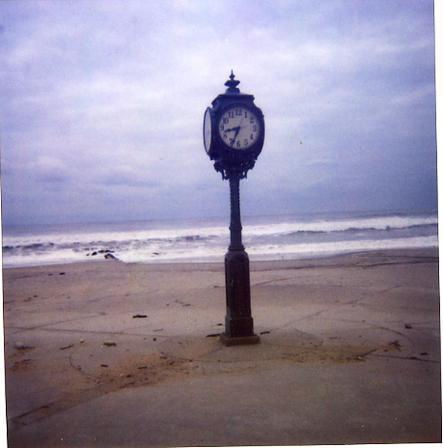How many waves are breaking on the beach?
Give a very brief answer. 2. How many faces would this clock have?
Give a very brief answer. 4. 